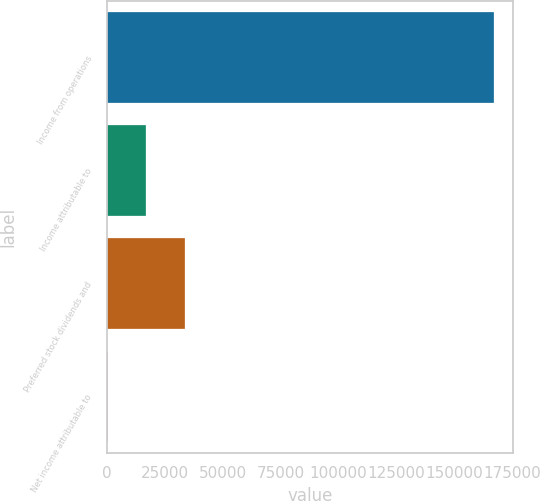<chart> <loc_0><loc_0><loc_500><loc_500><bar_chart><fcel>Income from operations<fcel>Income attributable to<fcel>Preferred stock dividends and<fcel>Net income attributable to<nl><fcel>166992<fcel>16930.5<fcel>33604<fcel>257<nl></chart> 